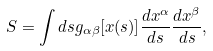Convert formula to latex. <formula><loc_0><loc_0><loc_500><loc_500>S = \int d s g _ { \alpha \beta } [ x ( s ) ] \frac { d x ^ { \alpha } } { d s } \frac { d x ^ { \beta } } { d s } ,</formula> 